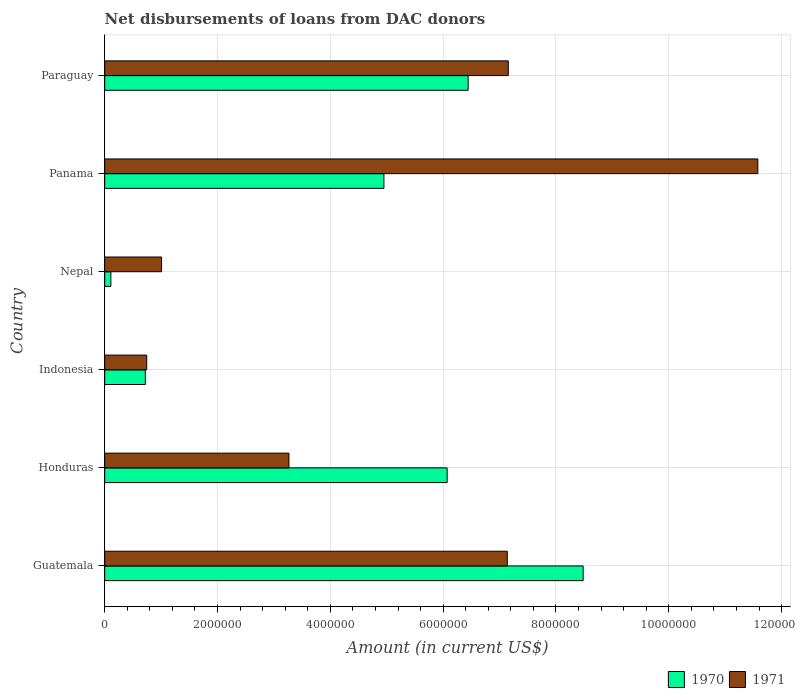How many different coloured bars are there?
Offer a very short reply. 2. Are the number of bars per tick equal to the number of legend labels?
Your response must be concise. Yes. Are the number of bars on each tick of the Y-axis equal?
Make the answer very short. Yes. In how many cases, is the number of bars for a given country not equal to the number of legend labels?
Your answer should be very brief. 0. What is the amount of loans disbursed in 1970 in Indonesia?
Provide a short and direct response. 7.20e+05. Across all countries, what is the maximum amount of loans disbursed in 1970?
Ensure brevity in your answer.  8.48e+06. Across all countries, what is the minimum amount of loans disbursed in 1971?
Keep it short and to the point. 7.45e+05. In which country was the amount of loans disbursed in 1970 maximum?
Your answer should be compact. Guatemala. In which country was the amount of loans disbursed in 1970 minimum?
Offer a very short reply. Nepal. What is the total amount of loans disbursed in 1970 in the graph?
Ensure brevity in your answer.  2.68e+07. What is the difference between the amount of loans disbursed in 1971 in Honduras and that in Panama?
Offer a very short reply. -8.31e+06. What is the difference between the amount of loans disbursed in 1970 in Honduras and the amount of loans disbursed in 1971 in Panama?
Make the answer very short. -5.51e+06. What is the average amount of loans disbursed in 1971 per country?
Offer a very short reply. 5.15e+06. What is the difference between the amount of loans disbursed in 1970 and amount of loans disbursed in 1971 in Paraguay?
Keep it short and to the point. -7.12e+05. What is the ratio of the amount of loans disbursed in 1970 in Honduras to that in Indonesia?
Provide a succinct answer. 8.43. Is the difference between the amount of loans disbursed in 1970 in Guatemala and Nepal greater than the difference between the amount of loans disbursed in 1971 in Guatemala and Nepal?
Offer a terse response. Yes. What is the difference between the highest and the second highest amount of loans disbursed in 1971?
Your response must be concise. 4.42e+06. What is the difference between the highest and the lowest amount of loans disbursed in 1970?
Your answer should be very brief. 8.37e+06. In how many countries, is the amount of loans disbursed in 1970 greater than the average amount of loans disbursed in 1970 taken over all countries?
Your response must be concise. 4. What does the 2nd bar from the top in Panama represents?
Offer a terse response. 1970. What does the 2nd bar from the bottom in Nepal represents?
Provide a short and direct response. 1971. How many bars are there?
Your answer should be compact. 12. How many countries are there in the graph?
Your answer should be compact. 6. What is the difference between two consecutive major ticks on the X-axis?
Offer a terse response. 2.00e+06. Are the values on the major ticks of X-axis written in scientific E-notation?
Provide a short and direct response. No. Does the graph contain grids?
Offer a terse response. Yes. Where does the legend appear in the graph?
Your answer should be compact. Bottom right. How many legend labels are there?
Your response must be concise. 2. How are the legend labels stacked?
Offer a very short reply. Horizontal. What is the title of the graph?
Offer a very short reply. Net disbursements of loans from DAC donors. What is the label or title of the X-axis?
Offer a very short reply. Amount (in current US$). What is the Amount (in current US$) of 1970 in Guatemala?
Provide a short and direct response. 8.48e+06. What is the Amount (in current US$) in 1971 in Guatemala?
Keep it short and to the point. 7.14e+06. What is the Amount (in current US$) in 1970 in Honduras?
Your response must be concise. 6.07e+06. What is the Amount (in current US$) of 1971 in Honduras?
Offer a terse response. 3.27e+06. What is the Amount (in current US$) of 1970 in Indonesia?
Make the answer very short. 7.20e+05. What is the Amount (in current US$) in 1971 in Indonesia?
Provide a succinct answer. 7.45e+05. What is the Amount (in current US$) of 1970 in Nepal?
Your answer should be very brief. 1.09e+05. What is the Amount (in current US$) in 1971 in Nepal?
Keep it short and to the point. 1.01e+06. What is the Amount (in current US$) of 1970 in Panama?
Ensure brevity in your answer.  4.95e+06. What is the Amount (in current US$) of 1971 in Panama?
Provide a succinct answer. 1.16e+07. What is the Amount (in current US$) in 1970 in Paraguay?
Provide a short and direct response. 6.44e+06. What is the Amount (in current US$) in 1971 in Paraguay?
Offer a very short reply. 7.16e+06. Across all countries, what is the maximum Amount (in current US$) in 1970?
Provide a succinct answer. 8.48e+06. Across all countries, what is the maximum Amount (in current US$) of 1971?
Give a very brief answer. 1.16e+07. Across all countries, what is the minimum Amount (in current US$) in 1970?
Give a very brief answer. 1.09e+05. Across all countries, what is the minimum Amount (in current US$) of 1971?
Your answer should be compact. 7.45e+05. What is the total Amount (in current US$) in 1970 in the graph?
Offer a terse response. 2.68e+07. What is the total Amount (in current US$) of 1971 in the graph?
Provide a succinct answer. 3.09e+07. What is the difference between the Amount (in current US$) in 1970 in Guatemala and that in Honduras?
Make the answer very short. 2.41e+06. What is the difference between the Amount (in current US$) in 1971 in Guatemala and that in Honduras?
Your answer should be compact. 3.87e+06. What is the difference between the Amount (in current US$) of 1970 in Guatemala and that in Indonesia?
Your answer should be very brief. 7.76e+06. What is the difference between the Amount (in current US$) in 1971 in Guatemala and that in Indonesia?
Keep it short and to the point. 6.39e+06. What is the difference between the Amount (in current US$) of 1970 in Guatemala and that in Nepal?
Offer a terse response. 8.37e+06. What is the difference between the Amount (in current US$) of 1971 in Guatemala and that in Nepal?
Your answer should be very brief. 6.13e+06. What is the difference between the Amount (in current US$) in 1970 in Guatemala and that in Panama?
Offer a very short reply. 3.53e+06. What is the difference between the Amount (in current US$) of 1971 in Guatemala and that in Panama?
Your response must be concise. -4.44e+06. What is the difference between the Amount (in current US$) of 1970 in Guatemala and that in Paraguay?
Make the answer very short. 2.04e+06. What is the difference between the Amount (in current US$) of 1971 in Guatemala and that in Paraguay?
Your answer should be compact. -1.80e+04. What is the difference between the Amount (in current US$) of 1970 in Honduras and that in Indonesia?
Offer a very short reply. 5.35e+06. What is the difference between the Amount (in current US$) of 1971 in Honduras and that in Indonesia?
Ensure brevity in your answer.  2.52e+06. What is the difference between the Amount (in current US$) of 1970 in Honduras and that in Nepal?
Give a very brief answer. 5.96e+06. What is the difference between the Amount (in current US$) of 1971 in Honduras and that in Nepal?
Ensure brevity in your answer.  2.26e+06. What is the difference between the Amount (in current US$) of 1970 in Honduras and that in Panama?
Your response must be concise. 1.12e+06. What is the difference between the Amount (in current US$) of 1971 in Honduras and that in Panama?
Keep it short and to the point. -8.31e+06. What is the difference between the Amount (in current US$) of 1970 in Honduras and that in Paraguay?
Your response must be concise. -3.72e+05. What is the difference between the Amount (in current US$) in 1971 in Honduras and that in Paraguay?
Give a very brief answer. -3.89e+06. What is the difference between the Amount (in current US$) in 1970 in Indonesia and that in Nepal?
Your response must be concise. 6.11e+05. What is the difference between the Amount (in current US$) in 1971 in Indonesia and that in Nepal?
Provide a succinct answer. -2.63e+05. What is the difference between the Amount (in current US$) in 1970 in Indonesia and that in Panama?
Give a very brief answer. -4.23e+06. What is the difference between the Amount (in current US$) of 1971 in Indonesia and that in Panama?
Keep it short and to the point. -1.08e+07. What is the difference between the Amount (in current US$) in 1970 in Indonesia and that in Paraguay?
Provide a succinct answer. -5.72e+06. What is the difference between the Amount (in current US$) of 1971 in Indonesia and that in Paraguay?
Your answer should be compact. -6.41e+06. What is the difference between the Amount (in current US$) in 1970 in Nepal and that in Panama?
Your answer should be very brief. -4.84e+06. What is the difference between the Amount (in current US$) of 1971 in Nepal and that in Panama?
Keep it short and to the point. -1.06e+07. What is the difference between the Amount (in current US$) in 1970 in Nepal and that in Paraguay?
Keep it short and to the point. -6.33e+06. What is the difference between the Amount (in current US$) in 1971 in Nepal and that in Paraguay?
Your answer should be very brief. -6.15e+06. What is the difference between the Amount (in current US$) in 1970 in Panama and that in Paraguay?
Provide a succinct answer. -1.49e+06. What is the difference between the Amount (in current US$) of 1971 in Panama and that in Paraguay?
Your response must be concise. 4.42e+06. What is the difference between the Amount (in current US$) in 1970 in Guatemala and the Amount (in current US$) in 1971 in Honduras?
Provide a succinct answer. 5.22e+06. What is the difference between the Amount (in current US$) of 1970 in Guatemala and the Amount (in current US$) of 1971 in Indonesia?
Offer a very short reply. 7.74e+06. What is the difference between the Amount (in current US$) of 1970 in Guatemala and the Amount (in current US$) of 1971 in Nepal?
Your answer should be compact. 7.47e+06. What is the difference between the Amount (in current US$) in 1970 in Guatemala and the Amount (in current US$) in 1971 in Panama?
Your answer should be compact. -3.10e+06. What is the difference between the Amount (in current US$) in 1970 in Guatemala and the Amount (in current US$) in 1971 in Paraguay?
Your response must be concise. 1.33e+06. What is the difference between the Amount (in current US$) of 1970 in Honduras and the Amount (in current US$) of 1971 in Indonesia?
Provide a succinct answer. 5.33e+06. What is the difference between the Amount (in current US$) in 1970 in Honduras and the Amount (in current US$) in 1971 in Nepal?
Your response must be concise. 5.06e+06. What is the difference between the Amount (in current US$) of 1970 in Honduras and the Amount (in current US$) of 1971 in Panama?
Provide a short and direct response. -5.51e+06. What is the difference between the Amount (in current US$) in 1970 in Honduras and the Amount (in current US$) in 1971 in Paraguay?
Your response must be concise. -1.08e+06. What is the difference between the Amount (in current US$) in 1970 in Indonesia and the Amount (in current US$) in 1971 in Nepal?
Keep it short and to the point. -2.88e+05. What is the difference between the Amount (in current US$) in 1970 in Indonesia and the Amount (in current US$) in 1971 in Panama?
Your answer should be very brief. -1.09e+07. What is the difference between the Amount (in current US$) of 1970 in Indonesia and the Amount (in current US$) of 1971 in Paraguay?
Ensure brevity in your answer.  -6.44e+06. What is the difference between the Amount (in current US$) in 1970 in Nepal and the Amount (in current US$) in 1971 in Panama?
Your answer should be compact. -1.15e+07. What is the difference between the Amount (in current US$) of 1970 in Nepal and the Amount (in current US$) of 1971 in Paraguay?
Ensure brevity in your answer.  -7.05e+06. What is the difference between the Amount (in current US$) of 1970 in Panama and the Amount (in current US$) of 1971 in Paraguay?
Keep it short and to the point. -2.20e+06. What is the average Amount (in current US$) of 1970 per country?
Make the answer very short. 4.46e+06. What is the average Amount (in current US$) in 1971 per country?
Ensure brevity in your answer.  5.15e+06. What is the difference between the Amount (in current US$) of 1970 and Amount (in current US$) of 1971 in Guatemala?
Provide a succinct answer. 1.34e+06. What is the difference between the Amount (in current US$) of 1970 and Amount (in current US$) of 1971 in Honduras?
Ensure brevity in your answer.  2.80e+06. What is the difference between the Amount (in current US$) of 1970 and Amount (in current US$) of 1971 in Indonesia?
Make the answer very short. -2.50e+04. What is the difference between the Amount (in current US$) in 1970 and Amount (in current US$) in 1971 in Nepal?
Your answer should be very brief. -8.99e+05. What is the difference between the Amount (in current US$) of 1970 and Amount (in current US$) of 1971 in Panama?
Your answer should be very brief. -6.63e+06. What is the difference between the Amount (in current US$) in 1970 and Amount (in current US$) in 1971 in Paraguay?
Provide a short and direct response. -7.12e+05. What is the ratio of the Amount (in current US$) of 1970 in Guatemala to that in Honduras?
Give a very brief answer. 1.4. What is the ratio of the Amount (in current US$) of 1971 in Guatemala to that in Honduras?
Offer a very short reply. 2.19. What is the ratio of the Amount (in current US$) in 1970 in Guatemala to that in Indonesia?
Offer a terse response. 11.78. What is the ratio of the Amount (in current US$) of 1971 in Guatemala to that in Indonesia?
Give a very brief answer. 9.58. What is the ratio of the Amount (in current US$) in 1970 in Guatemala to that in Nepal?
Give a very brief answer. 77.82. What is the ratio of the Amount (in current US$) of 1971 in Guatemala to that in Nepal?
Your response must be concise. 7.08. What is the ratio of the Amount (in current US$) of 1970 in Guatemala to that in Panama?
Your answer should be very brief. 1.71. What is the ratio of the Amount (in current US$) in 1971 in Guatemala to that in Panama?
Your response must be concise. 0.62. What is the ratio of the Amount (in current US$) of 1970 in Guatemala to that in Paraguay?
Give a very brief answer. 1.32. What is the ratio of the Amount (in current US$) in 1970 in Honduras to that in Indonesia?
Give a very brief answer. 8.43. What is the ratio of the Amount (in current US$) in 1971 in Honduras to that in Indonesia?
Your answer should be very brief. 4.38. What is the ratio of the Amount (in current US$) of 1970 in Honduras to that in Nepal?
Offer a very short reply. 55.7. What is the ratio of the Amount (in current US$) of 1971 in Honduras to that in Nepal?
Your response must be concise. 3.24. What is the ratio of the Amount (in current US$) in 1970 in Honduras to that in Panama?
Give a very brief answer. 1.23. What is the ratio of the Amount (in current US$) of 1971 in Honduras to that in Panama?
Your answer should be very brief. 0.28. What is the ratio of the Amount (in current US$) in 1970 in Honduras to that in Paraguay?
Offer a terse response. 0.94. What is the ratio of the Amount (in current US$) of 1971 in Honduras to that in Paraguay?
Make the answer very short. 0.46. What is the ratio of the Amount (in current US$) of 1970 in Indonesia to that in Nepal?
Your answer should be compact. 6.61. What is the ratio of the Amount (in current US$) in 1971 in Indonesia to that in Nepal?
Your answer should be very brief. 0.74. What is the ratio of the Amount (in current US$) in 1970 in Indonesia to that in Panama?
Keep it short and to the point. 0.15. What is the ratio of the Amount (in current US$) of 1971 in Indonesia to that in Panama?
Make the answer very short. 0.06. What is the ratio of the Amount (in current US$) of 1970 in Indonesia to that in Paraguay?
Your response must be concise. 0.11. What is the ratio of the Amount (in current US$) of 1971 in Indonesia to that in Paraguay?
Offer a terse response. 0.1. What is the ratio of the Amount (in current US$) of 1970 in Nepal to that in Panama?
Your answer should be very brief. 0.02. What is the ratio of the Amount (in current US$) in 1971 in Nepal to that in Panama?
Provide a succinct answer. 0.09. What is the ratio of the Amount (in current US$) of 1970 in Nepal to that in Paraguay?
Ensure brevity in your answer.  0.02. What is the ratio of the Amount (in current US$) of 1971 in Nepal to that in Paraguay?
Give a very brief answer. 0.14. What is the ratio of the Amount (in current US$) of 1970 in Panama to that in Paraguay?
Your answer should be very brief. 0.77. What is the ratio of the Amount (in current US$) in 1971 in Panama to that in Paraguay?
Your answer should be very brief. 1.62. What is the difference between the highest and the second highest Amount (in current US$) of 1970?
Provide a succinct answer. 2.04e+06. What is the difference between the highest and the second highest Amount (in current US$) of 1971?
Offer a very short reply. 4.42e+06. What is the difference between the highest and the lowest Amount (in current US$) of 1970?
Ensure brevity in your answer.  8.37e+06. What is the difference between the highest and the lowest Amount (in current US$) in 1971?
Ensure brevity in your answer.  1.08e+07. 